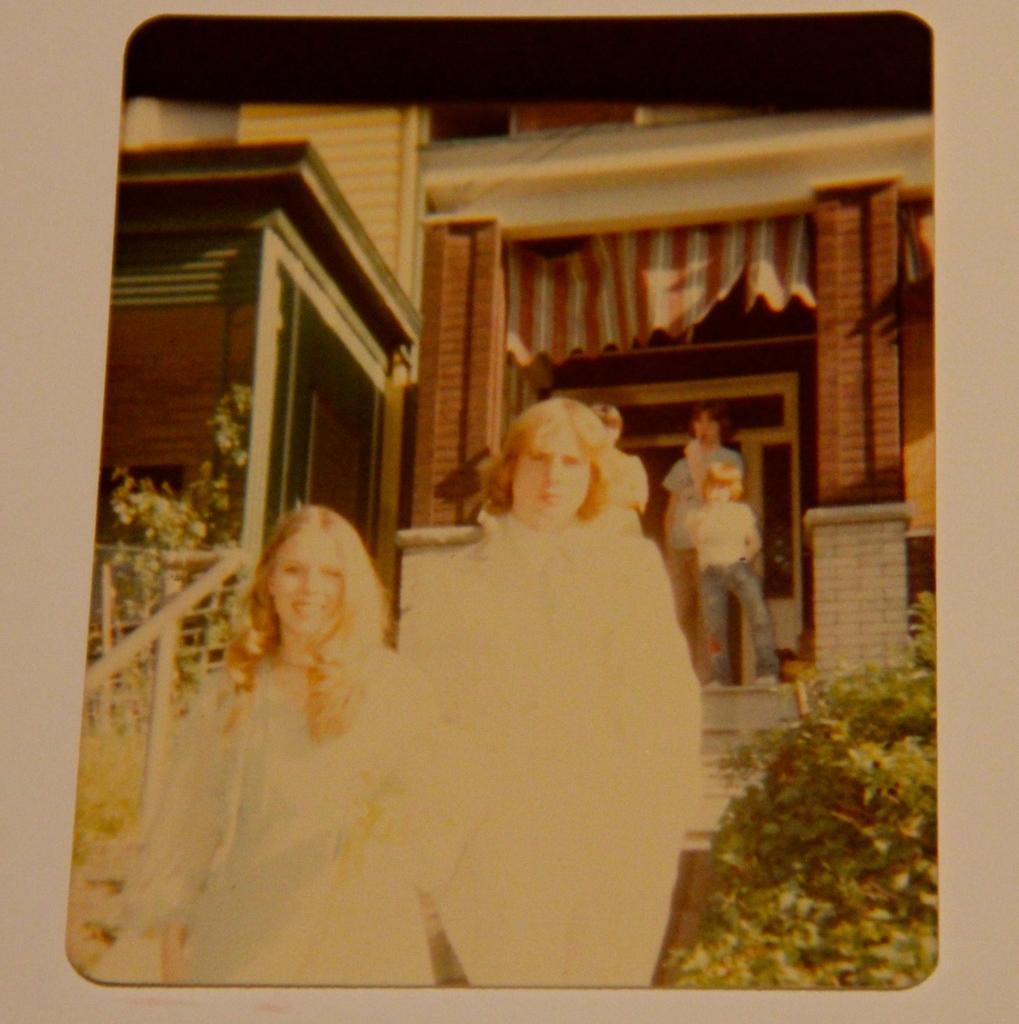Please provide a concise description of this image. In this picture I can see a photo frame and I can see this frame contains the picture of 2 women standing in front and in the background I can see a building, few plants and 3 persons standing and I can see the white and red color cloth. 